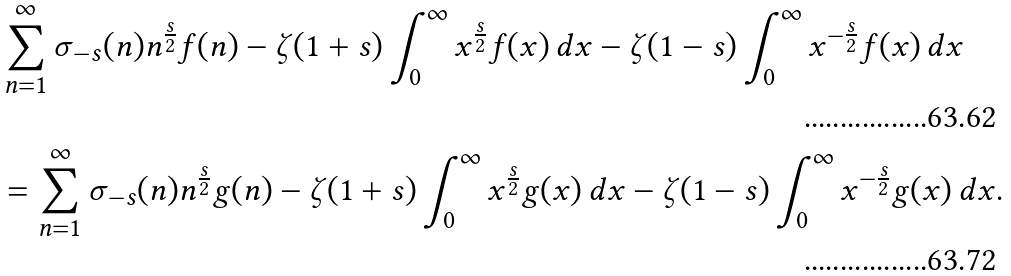Convert formula to latex. <formula><loc_0><loc_0><loc_500><loc_500>& \sum _ { n = 1 } ^ { \infty } \sigma _ { - s } ( n ) n ^ { \frac { s } { 2 } } f ( n ) - \zeta ( 1 + s ) \int _ { 0 } ^ { \infty } x ^ { \frac { s } { 2 } } f ( x ) \, d x - \zeta ( 1 - s ) \int _ { 0 } ^ { \infty } x ^ { - \frac { s } { 2 } } f ( x ) \, d x \\ & = \sum _ { n = 1 } ^ { \infty } \sigma _ { - s } ( n ) n ^ { \frac { s } { 2 } } g ( n ) - \zeta ( 1 + s ) \int _ { 0 } ^ { \infty } x ^ { \frac { s } { 2 } } g ( x ) \, d x - \zeta ( 1 - s ) \int _ { 0 } ^ { \infty } x ^ { - \frac { s } { 2 } } g ( x ) \, d x .</formula> 